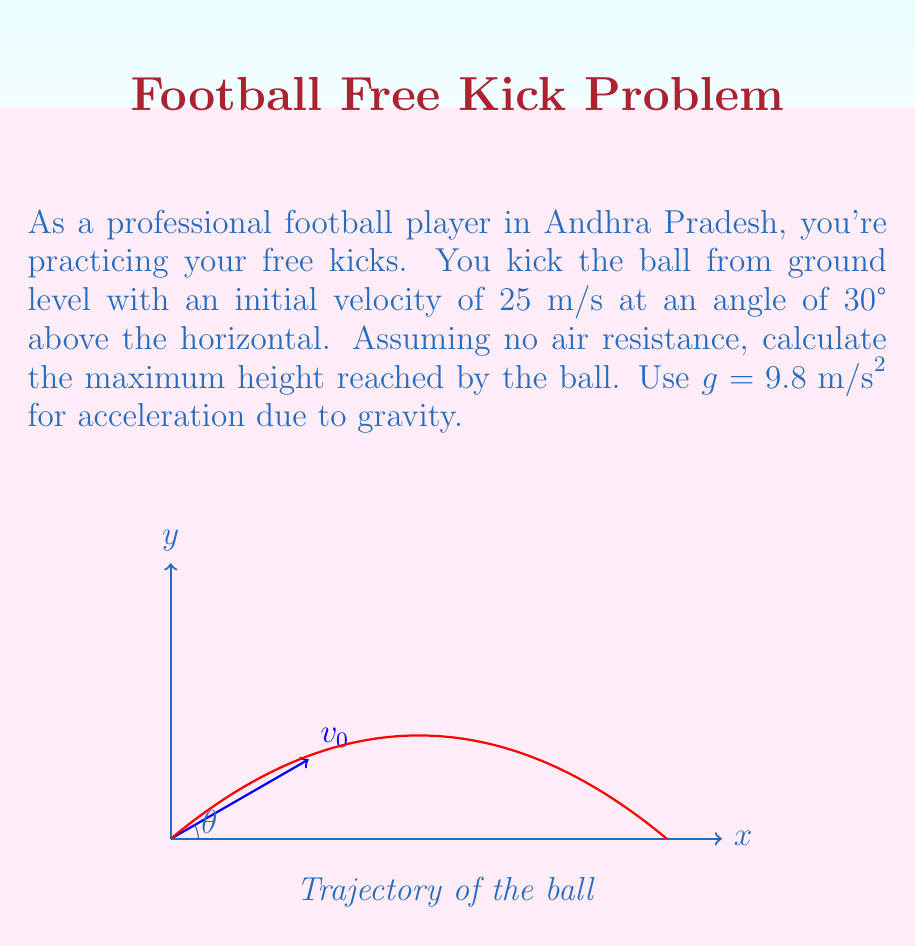Teach me how to tackle this problem. Let's approach this step-by-step using calculus:

1) The trajectory of a projectile (ignoring air resistance) is given by:

   $$y(t) = y_0 + v_0\sin(\theta)t - \frac{1}{2}gt^2$$

   where $y_0$ is the initial height (0 in this case), $v_0$ is the initial velocity, $\theta$ is the launch angle, and $t$ is time.

2) To find the maximum height, we need to find when the vertical velocity is zero. The vertical velocity is the derivative of $y(t)$:

   $$\frac{dy}{dt} = v_0\sin(\theta) - gt$$

3) Set this equal to zero and solve for $t$:

   $$v_0\sin(\theta) - gt = 0$$
   $$t = \frac{v_0\sin(\theta)}{g}$$

4) This gives us the time to reach the maximum height. Now, let's substitute the given values:

   $$t = \frac{25 \sin(30°)}{9.8} = \frac{25 * 0.5}{9.8} \approx 1.276 \text{ seconds}$$

5) Now, we can substitute this time back into our original equation for $y(t)$:

   $$y_{\text{max}} = 0 + 25\sin(30°)(1.276) - \frac{1}{2}(9.8)(1.276)^2$$

6) Simplify:

   $$y_{\text{max}} = 25(0.5)(1.276) - \frac{1}{2}(9.8)(1.276)^2$$
   $$y_{\text{max}} = 15.95 - 7.975 = 7.975 \text{ meters}$$

Therefore, the maximum height reached by the ball is approximately 7.975 meters.
Answer: $7.975 \text{ m}$ 